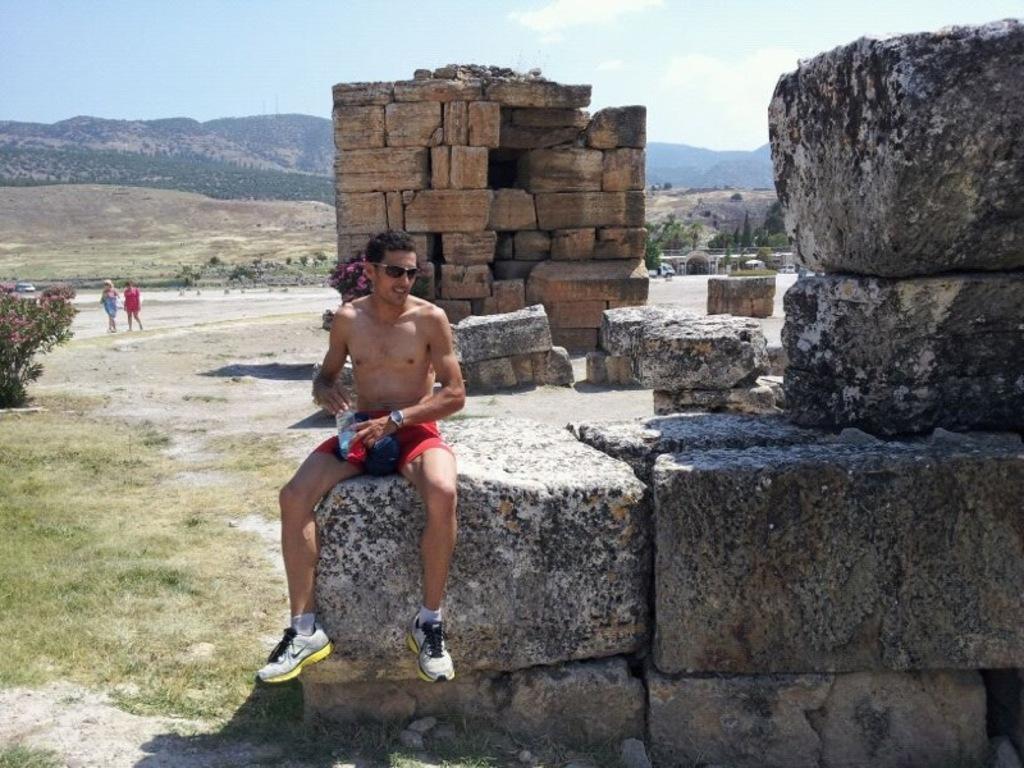Can you describe this image briefly? In this image, we can see a person is sitting on the wall and holding a bottle. Background we can see stone wall, plants grass, tree. Two people are walking here. Top of the image, we can see hills and sky. 